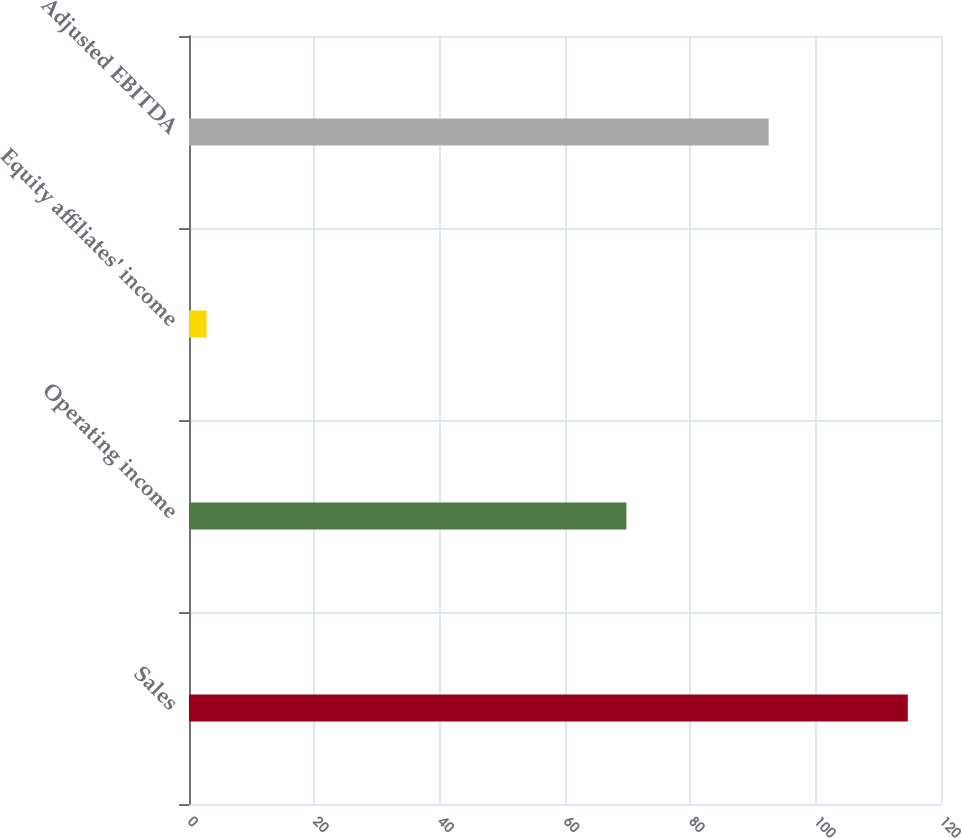<chart> <loc_0><loc_0><loc_500><loc_500><bar_chart><fcel>Sales<fcel>Operating income<fcel>Equity affiliates' income<fcel>Adjusted EBITDA<nl><fcel>114.7<fcel>69.8<fcel>2.8<fcel>92.5<nl></chart> 